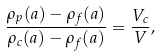<formula> <loc_0><loc_0><loc_500><loc_500>\frac { \rho _ { p } ( a ) - \rho _ { f } ( a ) } { \rho _ { c } ( a ) - \rho _ { f } ( a ) } = \frac { V _ { c } } { V } ,</formula> 